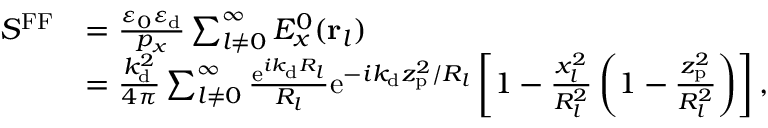<formula> <loc_0><loc_0><loc_500><loc_500>\begin{array} { r l } { S ^ { F F } } & { = \frac { \varepsilon _ { 0 } \varepsilon _ { d } } { p _ { x } } \sum _ { l \neq 0 } ^ { \infty } E _ { x } ^ { 0 } ( { r } _ { l } ) } \\ & { = \frac { k _ { d } ^ { 2 } } { 4 \pi } \sum _ { l \neq 0 } ^ { \infty } \frac { e ^ { i k _ { d } R _ { l } } } { R _ { l } } e ^ { - i k _ { d } z _ { p } ^ { 2 } / R _ { l } } \left [ 1 - \frac { x _ { l } ^ { 2 } } { R _ { l } ^ { 2 } } \left ( 1 - \frac { z _ { p } ^ { 2 } } { R _ { l } ^ { 2 } } \right ) \right ] , } \end{array}</formula> 